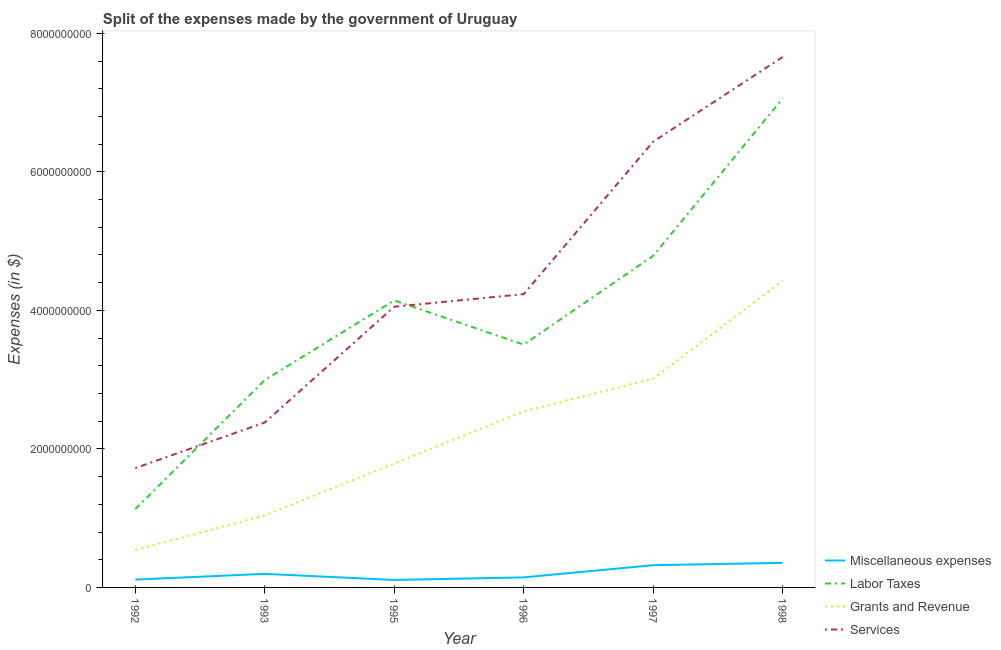Does the line corresponding to amount spent on grants and revenue intersect with the line corresponding to amount spent on services?
Make the answer very short. No. What is the amount spent on services in 1998?
Offer a terse response. 7.66e+09. Across all years, what is the maximum amount spent on labor taxes?
Provide a succinct answer. 7.06e+09. Across all years, what is the minimum amount spent on labor taxes?
Provide a short and direct response. 1.13e+09. What is the total amount spent on services in the graph?
Offer a very short reply. 2.65e+1. What is the difference between the amount spent on labor taxes in 1993 and that in 1997?
Ensure brevity in your answer.  -1.79e+09. What is the difference between the amount spent on services in 1997 and the amount spent on grants and revenue in 1995?
Give a very brief answer. 4.65e+09. What is the average amount spent on labor taxes per year?
Provide a succinct answer. 3.94e+09. In the year 1997, what is the difference between the amount spent on miscellaneous expenses and amount spent on grants and revenue?
Offer a very short reply. -2.69e+09. In how many years, is the amount spent on services greater than 2400000000 $?
Provide a short and direct response. 4. What is the ratio of the amount spent on miscellaneous expenses in 1997 to that in 1998?
Offer a very short reply. 0.9. Is the difference between the amount spent on miscellaneous expenses in 1992 and 1997 greater than the difference between the amount spent on grants and revenue in 1992 and 1997?
Your response must be concise. Yes. What is the difference between the highest and the second highest amount spent on labor taxes?
Keep it short and to the point. 2.27e+09. What is the difference between the highest and the lowest amount spent on labor taxes?
Ensure brevity in your answer.  5.93e+09. In how many years, is the amount spent on labor taxes greater than the average amount spent on labor taxes taken over all years?
Offer a very short reply. 3. Is the sum of the amount spent on grants and revenue in 1996 and 1997 greater than the maximum amount spent on services across all years?
Your answer should be very brief. No. Is it the case that in every year, the sum of the amount spent on services and amount spent on labor taxes is greater than the sum of amount spent on miscellaneous expenses and amount spent on grants and revenue?
Your answer should be compact. No. Is it the case that in every year, the sum of the amount spent on miscellaneous expenses and amount spent on labor taxes is greater than the amount spent on grants and revenue?
Provide a short and direct response. Yes. Is the amount spent on miscellaneous expenses strictly less than the amount spent on labor taxes over the years?
Offer a terse response. Yes. How many years are there in the graph?
Provide a succinct answer. 6. Are the values on the major ticks of Y-axis written in scientific E-notation?
Offer a terse response. No. Where does the legend appear in the graph?
Give a very brief answer. Bottom right. How many legend labels are there?
Keep it short and to the point. 4. How are the legend labels stacked?
Offer a very short reply. Vertical. What is the title of the graph?
Your answer should be very brief. Split of the expenses made by the government of Uruguay. What is the label or title of the X-axis?
Give a very brief answer. Year. What is the label or title of the Y-axis?
Ensure brevity in your answer.  Expenses (in $). What is the Expenses (in $) of Miscellaneous expenses in 1992?
Give a very brief answer. 1.13e+08. What is the Expenses (in $) of Labor Taxes in 1992?
Your answer should be compact. 1.13e+09. What is the Expenses (in $) in Grants and Revenue in 1992?
Make the answer very short. 5.40e+08. What is the Expenses (in $) of Services in 1992?
Provide a short and direct response. 1.72e+09. What is the Expenses (in $) in Miscellaneous expenses in 1993?
Offer a very short reply. 1.96e+08. What is the Expenses (in $) of Labor Taxes in 1993?
Provide a succinct answer. 2.99e+09. What is the Expenses (in $) of Grants and Revenue in 1993?
Make the answer very short. 1.04e+09. What is the Expenses (in $) in Services in 1993?
Offer a terse response. 2.38e+09. What is the Expenses (in $) in Miscellaneous expenses in 1995?
Keep it short and to the point. 1.08e+08. What is the Expenses (in $) of Labor Taxes in 1995?
Your answer should be very brief. 4.14e+09. What is the Expenses (in $) of Grants and Revenue in 1995?
Offer a terse response. 1.79e+09. What is the Expenses (in $) of Services in 1995?
Ensure brevity in your answer.  4.05e+09. What is the Expenses (in $) in Miscellaneous expenses in 1996?
Make the answer very short. 1.45e+08. What is the Expenses (in $) of Labor Taxes in 1996?
Give a very brief answer. 3.51e+09. What is the Expenses (in $) of Grants and Revenue in 1996?
Give a very brief answer. 2.54e+09. What is the Expenses (in $) of Services in 1996?
Provide a succinct answer. 4.24e+09. What is the Expenses (in $) in Miscellaneous expenses in 1997?
Your answer should be very brief. 3.21e+08. What is the Expenses (in $) in Labor Taxes in 1997?
Your response must be concise. 4.79e+09. What is the Expenses (in $) in Grants and Revenue in 1997?
Make the answer very short. 3.01e+09. What is the Expenses (in $) of Services in 1997?
Ensure brevity in your answer.  6.44e+09. What is the Expenses (in $) of Miscellaneous expenses in 1998?
Provide a short and direct response. 3.55e+08. What is the Expenses (in $) in Labor Taxes in 1998?
Offer a very short reply. 7.06e+09. What is the Expenses (in $) in Grants and Revenue in 1998?
Make the answer very short. 4.43e+09. What is the Expenses (in $) of Services in 1998?
Ensure brevity in your answer.  7.66e+09. Across all years, what is the maximum Expenses (in $) in Miscellaneous expenses?
Your answer should be compact. 3.55e+08. Across all years, what is the maximum Expenses (in $) of Labor Taxes?
Your answer should be compact. 7.06e+09. Across all years, what is the maximum Expenses (in $) of Grants and Revenue?
Make the answer very short. 4.43e+09. Across all years, what is the maximum Expenses (in $) in Services?
Your answer should be very brief. 7.66e+09. Across all years, what is the minimum Expenses (in $) of Miscellaneous expenses?
Provide a succinct answer. 1.08e+08. Across all years, what is the minimum Expenses (in $) of Labor Taxes?
Offer a terse response. 1.13e+09. Across all years, what is the minimum Expenses (in $) in Grants and Revenue?
Give a very brief answer. 5.40e+08. Across all years, what is the minimum Expenses (in $) in Services?
Keep it short and to the point. 1.72e+09. What is the total Expenses (in $) of Miscellaneous expenses in the graph?
Provide a succinct answer. 1.24e+09. What is the total Expenses (in $) in Labor Taxes in the graph?
Your answer should be very brief. 2.36e+1. What is the total Expenses (in $) of Grants and Revenue in the graph?
Offer a terse response. 1.34e+1. What is the total Expenses (in $) of Services in the graph?
Keep it short and to the point. 2.65e+1. What is the difference between the Expenses (in $) of Miscellaneous expenses in 1992 and that in 1993?
Make the answer very short. -8.30e+07. What is the difference between the Expenses (in $) in Labor Taxes in 1992 and that in 1993?
Give a very brief answer. -1.86e+09. What is the difference between the Expenses (in $) in Grants and Revenue in 1992 and that in 1993?
Offer a very short reply. -5.00e+08. What is the difference between the Expenses (in $) in Services in 1992 and that in 1993?
Offer a very short reply. -6.58e+08. What is the difference between the Expenses (in $) in Labor Taxes in 1992 and that in 1995?
Keep it short and to the point. -3.01e+09. What is the difference between the Expenses (in $) of Grants and Revenue in 1992 and that in 1995?
Keep it short and to the point. -1.25e+09. What is the difference between the Expenses (in $) of Services in 1992 and that in 1995?
Provide a short and direct response. -2.33e+09. What is the difference between the Expenses (in $) in Miscellaneous expenses in 1992 and that in 1996?
Your response must be concise. -3.20e+07. What is the difference between the Expenses (in $) of Labor Taxes in 1992 and that in 1996?
Provide a short and direct response. -2.38e+09. What is the difference between the Expenses (in $) of Grants and Revenue in 1992 and that in 1996?
Offer a very short reply. -2.00e+09. What is the difference between the Expenses (in $) of Services in 1992 and that in 1996?
Offer a very short reply. -2.51e+09. What is the difference between the Expenses (in $) of Miscellaneous expenses in 1992 and that in 1997?
Ensure brevity in your answer.  -2.08e+08. What is the difference between the Expenses (in $) in Labor Taxes in 1992 and that in 1997?
Your answer should be very brief. -3.66e+09. What is the difference between the Expenses (in $) in Grants and Revenue in 1992 and that in 1997?
Offer a terse response. -2.47e+09. What is the difference between the Expenses (in $) in Services in 1992 and that in 1997?
Offer a very short reply. -4.71e+09. What is the difference between the Expenses (in $) in Miscellaneous expenses in 1992 and that in 1998?
Your response must be concise. -2.42e+08. What is the difference between the Expenses (in $) in Labor Taxes in 1992 and that in 1998?
Offer a very short reply. -5.93e+09. What is the difference between the Expenses (in $) in Grants and Revenue in 1992 and that in 1998?
Offer a very short reply. -3.89e+09. What is the difference between the Expenses (in $) in Services in 1992 and that in 1998?
Your response must be concise. -5.94e+09. What is the difference between the Expenses (in $) of Miscellaneous expenses in 1993 and that in 1995?
Your answer should be very brief. 8.80e+07. What is the difference between the Expenses (in $) in Labor Taxes in 1993 and that in 1995?
Your answer should be compact. -1.15e+09. What is the difference between the Expenses (in $) in Grants and Revenue in 1993 and that in 1995?
Your answer should be compact. -7.50e+08. What is the difference between the Expenses (in $) of Services in 1993 and that in 1995?
Your answer should be compact. -1.67e+09. What is the difference between the Expenses (in $) of Miscellaneous expenses in 1993 and that in 1996?
Keep it short and to the point. 5.10e+07. What is the difference between the Expenses (in $) of Labor Taxes in 1993 and that in 1996?
Give a very brief answer. -5.12e+08. What is the difference between the Expenses (in $) in Grants and Revenue in 1993 and that in 1996?
Your answer should be compact. -1.50e+09. What is the difference between the Expenses (in $) of Services in 1993 and that in 1996?
Offer a very short reply. -1.85e+09. What is the difference between the Expenses (in $) in Miscellaneous expenses in 1993 and that in 1997?
Ensure brevity in your answer.  -1.25e+08. What is the difference between the Expenses (in $) of Labor Taxes in 1993 and that in 1997?
Your answer should be very brief. -1.79e+09. What is the difference between the Expenses (in $) in Grants and Revenue in 1993 and that in 1997?
Provide a short and direct response. -1.97e+09. What is the difference between the Expenses (in $) of Services in 1993 and that in 1997?
Offer a very short reply. -4.06e+09. What is the difference between the Expenses (in $) in Miscellaneous expenses in 1993 and that in 1998?
Your answer should be compact. -1.59e+08. What is the difference between the Expenses (in $) in Labor Taxes in 1993 and that in 1998?
Make the answer very short. -4.06e+09. What is the difference between the Expenses (in $) in Grants and Revenue in 1993 and that in 1998?
Provide a succinct answer. -3.39e+09. What is the difference between the Expenses (in $) of Services in 1993 and that in 1998?
Provide a short and direct response. -5.28e+09. What is the difference between the Expenses (in $) in Miscellaneous expenses in 1995 and that in 1996?
Keep it short and to the point. -3.70e+07. What is the difference between the Expenses (in $) of Labor Taxes in 1995 and that in 1996?
Provide a succinct answer. 6.38e+08. What is the difference between the Expenses (in $) in Grants and Revenue in 1995 and that in 1996?
Provide a succinct answer. -7.51e+08. What is the difference between the Expenses (in $) of Services in 1995 and that in 1996?
Offer a very short reply. -1.82e+08. What is the difference between the Expenses (in $) of Miscellaneous expenses in 1995 and that in 1997?
Your response must be concise. -2.13e+08. What is the difference between the Expenses (in $) of Labor Taxes in 1995 and that in 1997?
Provide a succinct answer. -6.44e+08. What is the difference between the Expenses (in $) of Grants and Revenue in 1995 and that in 1997?
Provide a short and direct response. -1.22e+09. What is the difference between the Expenses (in $) in Services in 1995 and that in 1997?
Provide a short and direct response. -2.38e+09. What is the difference between the Expenses (in $) of Miscellaneous expenses in 1995 and that in 1998?
Ensure brevity in your answer.  -2.47e+08. What is the difference between the Expenses (in $) of Labor Taxes in 1995 and that in 1998?
Your answer should be compact. -2.92e+09. What is the difference between the Expenses (in $) in Grants and Revenue in 1995 and that in 1998?
Your answer should be very brief. -2.64e+09. What is the difference between the Expenses (in $) of Services in 1995 and that in 1998?
Offer a very short reply. -3.61e+09. What is the difference between the Expenses (in $) in Miscellaneous expenses in 1996 and that in 1997?
Provide a short and direct response. -1.76e+08. What is the difference between the Expenses (in $) in Labor Taxes in 1996 and that in 1997?
Keep it short and to the point. -1.28e+09. What is the difference between the Expenses (in $) in Grants and Revenue in 1996 and that in 1997?
Your response must be concise. -4.73e+08. What is the difference between the Expenses (in $) in Services in 1996 and that in 1997?
Your answer should be compact. -2.20e+09. What is the difference between the Expenses (in $) of Miscellaneous expenses in 1996 and that in 1998?
Your answer should be compact. -2.10e+08. What is the difference between the Expenses (in $) in Labor Taxes in 1996 and that in 1998?
Make the answer very short. -3.55e+09. What is the difference between the Expenses (in $) in Grants and Revenue in 1996 and that in 1998?
Give a very brief answer. -1.89e+09. What is the difference between the Expenses (in $) in Services in 1996 and that in 1998?
Offer a very short reply. -3.42e+09. What is the difference between the Expenses (in $) in Miscellaneous expenses in 1997 and that in 1998?
Your response must be concise. -3.40e+07. What is the difference between the Expenses (in $) of Labor Taxes in 1997 and that in 1998?
Your response must be concise. -2.27e+09. What is the difference between the Expenses (in $) in Grants and Revenue in 1997 and that in 1998?
Offer a terse response. -1.41e+09. What is the difference between the Expenses (in $) in Services in 1997 and that in 1998?
Keep it short and to the point. -1.22e+09. What is the difference between the Expenses (in $) of Miscellaneous expenses in 1992 and the Expenses (in $) of Labor Taxes in 1993?
Your answer should be compact. -2.88e+09. What is the difference between the Expenses (in $) of Miscellaneous expenses in 1992 and the Expenses (in $) of Grants and Revenue in 1993?
Make the answer very short. -9.27e+08. What is the difference between the Expenses (in $) in Miscellaneous expenses in 1992 and the Expenses (in $) in Services in 1993?
Offer a terse response. -2.27e+09. What is the difference between the Expenses (in $) in Labor Taxes in 1992 and the Expenses (in $) in Grants and Revenue in 1993?
Your answer should be very brief. 9.00e+07. What is the difference between the Expenses (in $) of Labor Taxes in 1992 and the Expenses (in $) of Services in 1993?
Your answer should be compact. -1.25e+09. What is the difference between the Expenses (in $) in Grants and Revenue in 1992 and the Expenses (in $) in Services in 1993?
Your answer should be very brief. -1.84e+09. What is the difference between the Expenses (in $) in Miscellaneous expenses in 1992 and the Expenses (in $) in Labor Taxes in 1995?
Provide a succinct answer. -4.03e+09. What is the difference between the Expenses (in $) of Miscellaneous expenses in 1992 and the Expenses (in $) of Grants and Revenue in 1995?
Your answer should be compact. -1.68e+09. What is the difference between the Expenses (in $) of Miscellaneous expenses in 1992 and the Expenses (in $) of Services in 1995?
Give a very brief answer. -3.94e+09. What is the difference between the Expenses (in $) of Labor Taxes in 1992 and the Expenses (in $) of Grants and Revenue in 1995?
Make the answer very short. -6.60e+08. What is the difference between the Expenses (in $) of Labor Taxes in 1992 and the Expenses (in $) of Services in 1995?
Provide a succinct answer. -2.92e+09. What is the difference between the Expenses (in $) in Grants and Revenue in 1992 and the Expenses (in $) in Services in 1995?
Make the answer very short. -3.51e+09. What is the difference between the Expenses (in $) of Miscellaneous expenses in 1992 and the Expenses (in $) of Labor Taxes in 1996?
Offer a very short reply. -3.39e+09. What is the difference between the Expenses (in $) in Miscellaneous expenses in 1992 and the Expenses (in $) in Grants and Revenue in 1996?
Your answer should be very brief. -2.43e+09. What is the difference between the Expenses (in $) in Miscellaneous expenses in 1992 and the Expenses (in $) in Services in 1996?
Your response must be concise. -4.12e+09. What is the difference between the Expenses (in $) of Labor Taxes in 1992 and the Expenses (in $) of Grants and Revenue in 1996?
Offer a very short reply. -1.41e+09. What is the difference between the Expenses (in $) in Labor Taxes in 1992 and the Expenses (in $) in Services in 1996?
Give a very brief answer. -3.10e+09. What is the difference between the Expenses (in $) of Grants and Revenue in 1992 and the Expenses (in $) of Services in 1996?
Make the answer very short. -3.70e+09. What is the difference between the Expenses (in $) of Miscellaneous expenses in 1992 and the Expenses (in $) of Labor Taxes in 1997?
Provide a short and direct response. -4.68e+09. What is the difference between the Expenses (in $) of Miscellaneous expenses in 1992 and the Expenses (in $) of Grants and Revenue in 1997?
Keep it short and to the point. -2.90e+09. What is the difference between the Expenses (in $) of Miscellaneous expenses in 1992 and the Expenses (in $) of Services in 1997?
Ensure brevity in your answer.  -6.32e+09. What is the difference between the Expenses (in $) in Labor Taxes in 1992 and the Expenses (in $) in Grants and Revenue in 1997?
Your answer should be compact. -1.88e+09. What is the difference between the Expenses (in $) in Labor Taxes in 1992 and the Expenses (in $) in Services in 1997?
Offer a terse response. -5.31e+09. What is the difference between the Expenses (in $) of Grants and Revenue in 1992 and the Expenses (in $) of Services in 1997?
Keep it short and to the point. -5.90e+09. What is the difference between the Expenses (in $) in Miscellaneous expenses in 1992 and the Expenses (in $) in Labor Taxes in 1998?
Your answer should be compact. -6.95e+09. What is the difference between the Expenses (in $) of Miscellaneous expenses in 1992 and the Expenses (in $) of Grants and Revenue in 1998?
Provide a succinct answer. -4.32e+09. What is the difference between the Expenses (in $) of Miscellaneous expenses in 1992 and the Expenses (in $) of Services in 1998?
Keep it short and to the point. -7.55e+09. What is the difference between the Expenses (in $) of Labor Taxes in 1992 and the Expenses (in $) of Grants and Revenue in 1998?
Your answer should be very brief. -3.30e+09. What is the difference between the Expenses (in $) in Labor Taxes in 1992 and the Expenses (in $) in Services in 1998?
Keep it short and to the point. -6.53e+09. What is the difference between the Expenses (in $) of Grants and Revenue in 1992 and the Expenses (in $) of Services in 1998?
Give a very brief answer. -7.12e+09. What is the difference between the Expenses (in $) in Miscellaneous expenses in 1993 and the Expenses (in $) in Labor Taxes in 1995?
Your response must be concise. -3.95e+09. What is the difference between the Expenses (in $) of Miscellaneous expenses in 1993 and the Expenses (in $) of Grants and Revenue in 1995?
Provide a short and direct response. -1.59e+09. What is the difference between the Expenses (in $) in Miscellaneous expenses in 1993 and the Expenses (in $) in Services in 1995?
Keep it short and to the point. -3.86e+09. What is the difference between the Expenses (in $) in Labor Taxes in 1993 and the Expenses (in $) in Grants and Revenue in 1995?
Your answer should be very brief. 1.20e+09. What is the difference between the Expenses (in $) in Labor Taxes in 1993 and the Expenses (in $) in Services in 1995?
Keep it short and to the point. -1.06e+09. What is the difference between the Expenses (in $) in Grants and Revenue in 1993 and the Expenses (in $) in Services in 1995?
Make the answer very short. -3.01e+09. What is the difference between the Expenses (in $) in Miscellaneous expenses in 1993 and the Expenses (in $) in Labor Taxes in 1996?
Give a very brief answer. -3.31e+09. What is the difference between the Expenses (in $) of Miscellaneous expenses in 1993 and the Expenses (in $) of Grants and Revenue in 1996?
Your answer should be compact. -2.34e+09. What is the difference between the Expenses (in $) of Miscellaneous expenses in 1993 and the Expenses (in $) of Services in 1996?
Provide a short and direct response. -4.04e+09. What is the difference between the Expenses (in $) of Labor Taxes in 1993 and the Expenses (in $) of Grants and Revenue in 1996?
Your answer should be compact. 4.53e+08. What is the difference between the Expenses (in $) of Labor Taxes in 1993 and the Expenses (in $) of Services in 1996?
Offer a very short reply. -1.24e+09. What is the difference between the Expenses (in $) in Grants and Revenue in 1993 and the Expenses (in $) in Services in 1996?
Offer a very short reply. -3.20e+09. What is the difference between the Expenses (in $) of Miscellaneous expenses in 1993 and the Expenses (in $) of Labor Taxes in 1997?
Ensure brevity in your answer.  -4.59e+09. What is the difference between the Expenses (in $) of Miscellaneous expenses in 1993 and the Expenses (in $) of Grants and Revenue in 1997?
Give a very brief answer. -2.82e+09. What is the difference between the Expenses (in $) in Miscellaneous expenses in 1993 and the Expenses (in $) in Services in 1997?
Provide a succinct answer. -6.24e+09. What is the difference between the Expenses (in $) in Labor Taxes in 1993 and the Expenses (in $) in Grants and Revenue in 1997?
Ensure brevity in your answer.  -2.00e+07. What is the difference between the Expenses (in $) in Labor Taxes in 1993 and the Expenses (in $) in Services in 1997?
Your answer should be very brief. -3.44e+09. What is the difference between the Expenses (in $) in Grants and Revenue in 1993 and the Expenses (in $) in Services in 1997?
Make the answer very short. -5.40e+09. What is the difference between the Expenses (in $) of Miscellaneous expenses in 1993 and the Expenses (in $) of Labor Taxes in 1998?
Offer a very short reply. -6.86e+09. What is the difference between the Expenses (in $) in Miscellaneous expenses in 1993 and the Expenses (in $) in Grants and Revenue in 1998?
Keep it short and to the point. -4.23e+09. What is the difference between the Expenses (in $) of Miscellaneous expenses in 1993 and the Expenses (in $) of Services in 1998?
Ensure brevity in your answer.  -7.46e+09. What is the difference between the Expenses (in $) in Labor Taxes in 1993 and the Expenses (in $) in Grants and Revenue in 1998?
Provide a succinct answer. -1.43e+09. What is the difference between the Expenses (in $) in Labor Taxes in 1993 and the Expenses (in $) in Services in 1998?
Make the answer very short. -4.66e+09. What is the difference between the Expenses (in $) of Grants and Revenue in 1993 and the Expenses (in $) of Services in 1998?
Provide a short and direct response. -6.62e+09. What is the difference between the Expenses (in $) of Miscellaneous expenses in 1995 and the Expenses (in $) of Labor Taxes in 1996?
Offer a very short reply. -3.40e+09. What is the difference between the Expenses (in $) in Miscellaneous expenses in 1995 and the Expenses (in $) in Grants and Revenue in 1996?
Offer a very short reply. -2.43e+09. What is the difference between the Expenses (in $) of Miscellaneous expenses in 1995 and the Expenses (in $) of Services in 1996?
Your answer should be compact. -4.13e+09. What is the difference between the Expenses (in $) in Labor Taxes in 1995 and the Expenses (in $) in Grants and Revenue in 1996?
Offer a terse response. 1.60e+09. What is the difference between the Expenses (in $) of Labor Taxes in 1995 and the Expenses (in $) of Services in 1996?
Provide a short and direct response. -9.10e+07. What is the difference between the Expenses (in $) of Grants and Revenue in 1995 and the Expenses (in $) of Services in 1996?
Provide a short and direct response. -2.44e+09. What is the difference between the Expenses (in $) in Miscellaneous expenses in 1995 and the Expenses (in $) in Labor Taxes in 1997?
Your answer should be compact. -4.68e+09. What is the difference between the Expenses (in $) of Miscellaneous expenses in 1995 and the Expenses (in $) of Grants and Revenue in 1997?
Your answer should be very brief. -2.91e+09. What is the difference between the Expenses (in $) of Miscellaneous expenses in 1995 and the Expenses (in $) of Services in 1997?
Keep it short and to the point. -6.33e+09. What is the difference between the Expenses (in $) of Labor Taxes in 1995 and the Expenses (in $) of Grants and Revenue in 1997?
Offer a very short reply. 1.13e+09. What is the difference between the Expenses (in $) in Labor Taxes in 1995 and the Expenses (in $) in Services in 1997?
Keep it short and to the point. -2.29e+09. What is the difference between the Expenses (in $) of Grants and Revenue in 1995 and the Expenses (in $) of Services in 1997?
Your answer should be very brief. -4.65e+09. What is the difference between the Expenses (in $) in Miscellaneous expenses in 1995 and the Expenses (in $) in Labor Taxes in 1998?
Make the answer very short. -6.95e+09. What is the difference between the Expenses (in $) of Miscellaneous expenses in 1995 and the Expenses (in $) of Grants and Revenue in 1998?
Keep it short and to the point. -4.32e+09. What is the difference between the Expenses (in $) in Miscellaneous expenses in 1995 and the Expenses (in $) in Services in 1998?
Provide a short and direct response. -7.55e+09. What is the difference between the Expenses (in $) of Labor Taxes in 1995 and the Expenses (in $) of Grants and Revenue in 1998?
Your response must be concise. -2.84e+08. What is the difference between the Expenses (in $) in Labor Taxes in 1995 and the Expenses (in $) in Services in 1998?
Provide a succinct answer. -3.52e+09. What is the difference between the Expenses (in $) of Grants and Revenue in 1995 and the Expenses (in $) of Services in 1998?
Provide a succinct answer. -5.87e+09. What is the difference between the Expenses (in $) in Miscellaneous expenses in 1996 and the Expenses (in $) in Labor Taxes in 1997?
Your answer should be very brief. -4.64e+09. What is the difference between the Expenses (in $) in Miscellaneous expenses in 1996 and the Expenses (in $) in Grants and Revenue in 1997?
Keep it short and to the point. -2.87e+09. What is the difference between the Expenses (in $) of Miscellaneous expenses in 1996 and the Expenses (in $) of Services in 1997?
Make the answer very short. -6.29e+09. What is the difference between the Expenses (in $) in Labor Taxes in 1996 and the Expenses (in $) in Grants and Revenue in 1997?
Offer a very short reply. 4.92e+08. What is the difference between the Expenses (in $) in Labor Taxes in 1996 and the Expenses (in $) in Services in 1997?
Ensure brevity in your answer.  -2.93e+09. What is the difference between the Expenses (in $) of Grants and Revenue in 1996 and the Expenses (in $) of Services in 1997?
Ensure brevity in your answer.  -3.90e+09. What is the difference between the Expenses (in $) of Miscellaneous expenses in 1996 and the Expenses (in $) of Labor Taxes in 1998?
Provide a succinct answer. -6.91e+09. What is the difference between the Expenses (in $) of Miscellaneous expenses in 1996 and the Expenses (in $) of Grants and Revenue in 1998?
Offer a very short reply. -4.28e+09. What is the difference between the Expenses (in $) in Miscellaneous expenses in 1996 and the Expenses (in $) in Services in 1998?
Make the answer very short. -7.51e+09. What is the difference between the Expenses (in $) of Labor Taxes in 1996 and the Expenses (in $) of Grants and Revenue in 1998?
Provide a short and direct response. -9.22e+08. What is the difference between the Expenses (in $) in Labor Taxes in 1996 and the Expenses (in $) in Services in 1998?
Ensure brevity in your answer.  -4.15e+09. What is the difference between the Expenses (in $) of Grants and Revenue in 1996 and the Expenses (in $) of Services in 1998?
Offer a terse response. -5.12e+09. What is the difference between the Expenses (in $) in Miscellaneous expenses in 1997 and the Expenses (in $) in Labor Taxes in 1998?
Provide a short and direct response. -6.74e+09. What is the difference between the Expenses (in $) in Miscellaneous expenses in 1997 and the Expenses (in $) in Grants and Revenue in 1998?
Your response must be concise. -4.11e+09. What is the difference between the Expenses (in $) in Miscellaneous expenses in 1997 and the Expenses (in $) in Services in 1998?
Provide a short and direct response. -7.34e+09. What is the difference between the Expenses (in $) in Labor Taxes in 1997 and the Expenses (in $) in Grants and Revenue in 1998?
Offer a very short reply. 3.60e+08. What is the difference between the Expenses (in $) of Labor Taxes in 1997 and the Expenses (in $) of Services in 1998?
Give a very brief answer. -2.87e+09. What is the difference between the Expenses (in $) in Grants and Revenue in 1997 and the Expenses (in $) in Services in 1998?
Provide a short and direct response. -4.64e+09. What is the average Expenses (in $) of Miscellaneous expenses per year?
Offer a terse response. 2.06e+08. What is the average Expenses (in $) of Labor Taxes per year?
Your answer should be very brief. 3.94e+09. What is the average Expenses (in $) in Grants and Revenue per year?
Offer a very short reply. 2.23e+09. What is the average Expenses (in $) in Services per year?
Your response must be concise. 4.41e+09. In the year 1992, what is the difference between the Expenses (in $) of Miscellaneous expenses and Expenses (in $) of Labor Taxes?
Provide a succinct answer. -1.02e+09. In the year 1992, what is the difference between the Expenses (in $) of Miscellaneous expenses and Expenses (in $) of Grants and Revenue?
Your response must be concise. -4.27e+08. In the year 1992, what is the difference between the Expenses (in $) in Miscellaneous expenses and Expenses (in $) in Services?
Give a very brief answer. -1.61e+09. In the year 1992, what is the difference between the Expenses (in $) in Labor Taxes and Expenses (in $) in Grants and Revenue?
Your response must be concise. 5.90e+08. In the year 1992, what is the difference between the Expenses (in $) of Labor Taxes and Expenses (in $) of Services?
Keep it short and to the point. -5.93e+08. In the year 1992, what is the difference between the Expenses (in $) in Grants and Revenue and Expenses (in $) in Services?
Make the answer very short. -1.18e+09. In the year 1993, what is the difference between the Expenses (in $) of Miscellaneous expenses and Expenses (in $) of Labor Taxes?
Provide a short and direct response. -2.80e+09. In the year 1993, what is the difference between the Expenses (in $) of Miscellaneous expenses and Expenses (in $) of Grants and Revenue?
Give a very brief answer. -8.44e+08. In the year 1993, what is the difference between the Expenses (in $) of Miscellaneous expenses and Expenses (in $) of Services?
Your answer should be compact. -2.18e+09. In the year 1993, what is the difference between the Expenses (in $) of Labor Taxes and Expenses (in $) of Grants and Revenue?
Your response must be concise. 1.95e+09. In the year 1993, what is the difference between the Expenses (in $) in Labor Taxes and Expenses (in $) in Services?
Give a very brief answer. 6.13e+08. In the year 1993, what is the difference between the Expenses (in $) of Grants and Revenue and Expenses (in $) of Services?
Ensure brevity in your answer.  -1.34e+09. In the year 1995, what is the difference between the Expenses (in $) in Miscellaneous expenses and Expenses (in $) in Labor Taxes?
Make the answer very short. -4.04e+09. In the year 1995, what is the difference between the Expenses (in $) in Miscellaneous expenses and Expenses (in $) in Grants and Revenue?
Your response must be concise. -1.68e+09. In the year 1995, what is the difference between the Expenses (in $) in Miscellaneous expenses and Expenses (in $) in Services?
Your answer should be very brief. -3.94e+09. In the year 1995, what is the difference between the Expenses (in $) in Labor Taxes and Expenses (in $) in Grants and Revenue?
Provide a succinct answer. 2.35e+09. In the year 1995, what is the difference between the Expenses (in $) in Labor Taxes and Expenses (in $) in Services?
Your answer should be compact. 9.10e+07. In the year 1995, what is the difference between the Expenses (in $) of Grants and Revenue and Expenses (in $) of Services?
Keep it short and to the point. -2.26e+09. In the year 1996, what is the difference between the Expenses (in $) of Miscellaneous expenses and Expenses (in $) of Labor Taxes?
Give a very brief answer. -3.36e+09. In the year 1996, what is the difference between the Expenses (in $) in Miscellaneous expenses and Expenses (in $) in Grants and Revenue?
Provide a succinct answer. -2.40e+09. In the year 1996, what is the difference between the Expenses (in $) of Miscellaneous expenses and Expenses (in $) of Services?
Make the answer very short. -4.09e+09. In the year 1996, what is the difference between the Expenses (in $) of Labor Taxes and Expenses (in $) of Grants and Revenue?
Make the answer very short. 9.65e+08. In the year 1996, what is the difference between the Expenses (in $) of Labor Taxes and Expenses (in $) of Services?
Offer a very short reply. -7.29e+08. In the year 1996, what is the difference between the Expenses (in $) of Grants and Revenue and Expenses (in $) of Services?
Offer a very short reply. -1.69e+09. In the year 1997, what is the difference between the Expenses (in $) of Miscellaneous expenses and Expenses (in $) of Labor Taxes?
Your response must be concise. -4.47e+09. In the year 1997, what is the difference between the Expenses (in $) of Miscellaneous expenses and Expenses (in $) of Grants and Revenue?
Provide a succinct answer. -2.69e+09. In the year 1997, what is the difference between the Expenses (in $) of Miscellaneous expenses and Expenses (in $) of Services?
Your answer should be very brief. -6.12e+09. In the year 1997, what is the difference between the Expenses (in $) in Labor Taxes and Expenses (in $) in Grants and Revenue?
Offer a terse response. 1.77e+09. In the year 1997, what is the difference between the Expenses (in $) of Labor Taxes and Expenses (in $) of Services?
Offer a very short reply. -1.65e+09. In the year 1997, what is the difference between the Expenses (in $) in Grants and Revenue and Expenses (in $) in Services?
Ensure brevity in your answer.  -3.42e+09. In the year 1998, what is the difference between the Expenses (in $) in Miscellaneous expenses and Expenses (in $) in Labor Taxes?
Offer a very short reply. -6.70e+09. In the year 1998, what is the difference between the Expenses (in $) in Miscellaneous expenses and Expenses (in $) in Grants and Revenue?
Provide a succinct answer. -4.07e+09. In the year 1998, what is the difference between the Expenses (in $) in Miscellaneous expenses and Expenses (in $) in Services?
Give a very brief answer. -7.30e+09. In the year 1998, what is the difference between the Expenses (in $) of Labor Taxes and Expenses (in $) of Grants and Revenue?
Your response must be concise. 2.63e+09. In the year 1998, what is the difference between the Expenses (in $) of Labor Taxes and Expenses (in $) of Services?
Ensure brevity in your answer.  -6.00e+08. In the year 1998, what is the difference between the Expenses (in $) of Grants and Revenue and Expenses (in $) of Services?
Your answer should be very brief. -3.23e+09. What is the ratio of the Expenses (in $) in Miscellaneous expenses in 1992 to that in 1993?
Your answer should be compact. 0.58. What is the ratio of the Expenses (in $) of Labor Taxes in 1992 to that in 1993?
Offer a terse response. 0.38. What is the ratio of the Expenses (in $) of Grants and Revenue in 1992 to that in 1993?
Provide a short and direct response. 0.52. What is the ratio of the Expenses (in $) in Services in 1992 to that in 1993?
Offer a very short reply. 0.72. What is the ratio of the Expenses (in $) of Miscellaneous expenses in 1992 to that in 1995?
Provide a succinct answer. 1.05. What is the ratio of the Expenses (in $) of Labor Taxes in 1992 to that in 1995?
Your response must be concise. 0.27. What is the ratio of the Expenses (in $) in Grants and Revenue in 1992 to that in 1995?
Ensure brevity in your answer.  0.3. What is the ratio of the Expenses (in $) of Services in 1992 to that in 1995?
Provide a succinct answer. 0.43. What is the ratio of the Expenses (in $) in Miscellaneous expenses in 1992 to that in 1996?
Give a very brief answer. 0.78. What is the ratio of the Expenses (in $) of Labor Taxes in 1992 to that in 1996?
Offer a very short reply. 0.32. What is the ratio of the Expenses (in $) of Grants and Revenue in 1992 to that in 1996?
Your answer should be very brief. 0.21. What is the ratio of the Expenses (in $) of Services in 1992 to that in 1996?
Your answer should be very brief. 0.41. What is the ratio of the Expenses (in $) in Miscellaneous expenses in 1992 to that in 1997?
Keep it short and to the point. 0.35. What is the ratio of the Expenses (in $) of Labor Taxes in 1992 to that in 1997?
Offer a terse response. 0.24. What is the ratio of the Expenses (in $) of Grants and Revenue in 1992 to that in 1997?
Your answer should be compact. 0.18. What is the ratio of the Expenses (in $) in Services in 1992 to that in 1997?
Your response must be concise. 0.27. What is the ratio of the Expenses (in $) of Miscellaneous expenses in 1992 to that in 1998?
Provide a short and direct response. 0.32. What is the ratio of the Expenses (in $) of Labor Taxes in 1992 to that in 1998?
Give a very brief answer. 0.16. What is the ratio of the Expenses (in $) of Grants and Revenue in 1992 to that in 1998?
Ensure brevity in your answer.  0.12. What is the ratio of the Expenses (in $) in Services in 1992 to that in 1998?
Offer a very short reply. 0.23. What is the ratio of the Expenses (in $) in Miscellaneous expenses in 1993 to that in 1995?
Your response must be concise. 1.81. What is the ratio of the Expenses (in $) in Labor Taxes in 1993 to that in 1995?
Keep it short and to the point. 0.72. What is the ratio of the Expenses (in $) in Grants and Revenue in 1993 to that in 1995?
Make the answer very short. 0.58. What is the ratio of the Expenses (in $) in Services in 1993 to that in 1995?
Keep it short and to the point. 0.59. What is the ratio of the Expenses (in $) in Miscellaneous expenses in 1993 to that in 1996?
Your response must be concise. 1.35. What is the ratio of the Expenses (in $) in Labor Taxes in 1993 to that in 1996?
Your answer should be compact. 0.85. What is the ratio of the Expenses (in $) in Grants and Revenue in 1993 to that in 1996?
Your response must be concise. 0.41. What is the ratio of the Expenses (in $) of Services in 1993 to that in 1996?
Ensure brevity in your answer.  0.56. What is the ratio of the Expenses (in $) of Miscellaneous expenses in 1993 to that in 1997?
Keep it short and to the point. 0.61. What is the ratio of the Expenses (in $) in Labor Taxes in 1993 to that in 1997?
Your answer should be compact. 0.63. What is the ratio of the Expenses (in $) in Grants and Revenue in 1993 to that in 1997?
Ensure brevity in your answer.  0.35. What is the ratio of the Expenses (in $) in Services in 1993 to that in 1997?
Provide a short and direct response. 0.37. What is the ratio of the Expenses (in $) of Miscellaneous expenses in 1993 to that in 1998?
Provide a succinct answer. 0.55. What is the ratio of the Expenses (in $) in Labor Taxes in 1993 to that in 1998?
Offer a very short reply. 0.42. What is the ratio of the Expenses (in $) in Grants and Revenue in 1993 to that in 1998?
Offer a very short reply. 0.23. What is the ratio of the Expenses (in $) in Services in 1993 to that in 1998?
Offer a very short reply. 0.31. What is the ratio of the Expenses (in $) of Miscellaneous expenses in 1995 to that in 1996?
Provide a succinct answer. 0.74. What is the ratio of the Expenses (in $) of Labor Taxes in 1995 to that in 1996?
Offer a very short reply. 1.18. What is the ratio of the Expenses (in $) of Grants and Revenue in 1995 to that in 1996?
Your answer should be very brief. 0.7. What is the ratio of the Expenses (in $) of Miscellaneous expenses in 1995 to that in 1997?
Offer a very short reply. 0.34. What is the ratio of the Expenses (in $) of Labor Taxes in 1995 to that in 1997?
Provide a short and direct response. 0.87. What is the ratio of the Expenses (in $) of Grants and Revenue in 1995 to that in 1997?
Offer a terse response. 0.59. What is the ratio of the Expenses (in $) of Services in 1995 to that in 1997?
Keep it short and to the point. 0.63. What is the ratio of the Expenses (in $) in Miscellaneous expenses in 1995 to that in 1998?
Provide a short and direct response. 0.3. What is the ratio of the Expenses (in $) of Labor Taxes in 1995 to that in 1998?
Make the answer very short. 0.59. What is the ratio of the Expenses (in $) in Grants and Revenue in 1995 to that in 1998?
Keep it short and to the point. 0.4. What is the ratio of the Expenses (in $) of Services in 1995 to that in 1998?
Keep it short and to the point. 0.53. What is the ratio of the Expenses (in $) in Miscellaneous expenses in 1996 to that in 1997?
Offer a very short reply. 0.45. What is the ratio of the Expenses (in $) of Labor Taxes in 1996 to that in 1997?
Make the answer very short. 0.73. What is the ratio of the Expenses (in $) in Grants and Revenue in 1996 to that in 1997?
Your answer should be compact. 0.84. What is the ratio of the Expenses (in $) of Services in 1996 to that in 1997?
Give a very brief answer. 0.66. What is the ratio of the Expenses (in $) of Miscellaneous expenses in 1996 to that in 1998?
Your response must be concise. 0.41. What is the ratio of the Expenses (in $) in Labor Taxes in 1996 to that in 1998?
Give a very brief answer. 0.5. What is the ratio of the Expenses (in $) of Grants and Revenue in 1996 to that in 1998?
Your response must be concise. 0.57. What is the ratio of the Expenses (in $) of Services in 1996 to that in 1998?
Make the answer very short. 0.55. What is the ratio of the Expenses (in $) of Miscellaneous expenses in 1997 to that in 1998?
Offer a very short reply. 0.9. What is the ratio of the Expenses (in $) of Labor Taxes in 1997 to that in 1998?
Your answer should be compact. 0.68. What is the ratio of the Expenses (in $) in Grants and Revenue in 1997 to that in 1998?
Your answer should be very brief. 0.68. What is the ratio of the Expenses (in $) in Services in 1997 to that in 1998?
Offer a terse response. 0.84. What is the difference between the highest and the second highest Expenses (in $) of Miscellaneous expenses?
Your response must be concise. 3.40e+07. What is the difference between the highest and the second highest Expenses (in $) in Labor Taxes?
Your answer should be compact. 2.27e+09. What is the difference between the highest and the second highest Expenses (in $) in Grants and Revenue?
Provide a succinct answer. 1.41e+09. What is the difference between the highest and the second highest Expenses (in $) of Services?
Provide a succinct answer. 1.22e+09. What is the difference between the highest and the lowest Expenses (in $) in Miscellaneous expenses?
Provide a short and direct response. 2.47e+08. What is the difference between the highest and the lowest Expenses (in $) in Labor Taxes?
Your answer should be compact. 5.93e+09. What is the difference between the highest and the lowest Expenses (in $) of Grants and Revenue?
Provide a short and direct response. 3.89e+09. What is the difference between the highest and the lowest Expenses (in $) in Services?
Offer a terse response. 5.94e+09. 